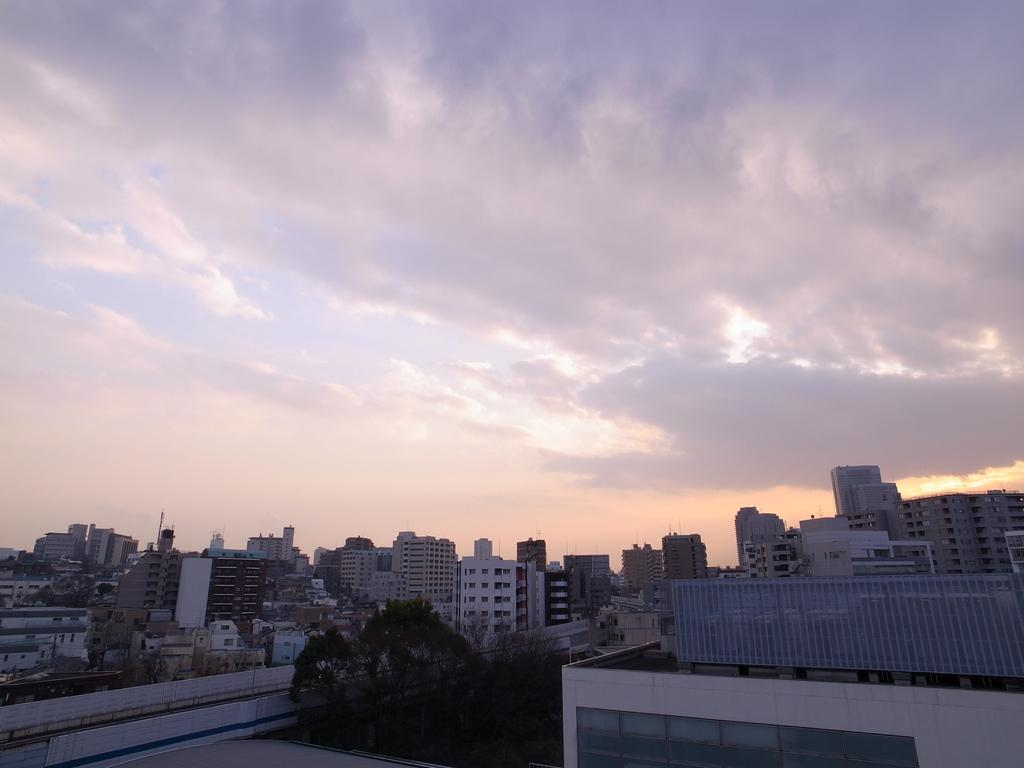What type of structures can be seen in the image? There are buildings in the image. What type of vegetation is present in the image? There are trees in the image. What is the condition of the sky in the image? The sky is cloudy in the image. Can you tell me how many women are wearing underwear in the image? There is no woman or underwear present in the image; it features buildings and trees. 